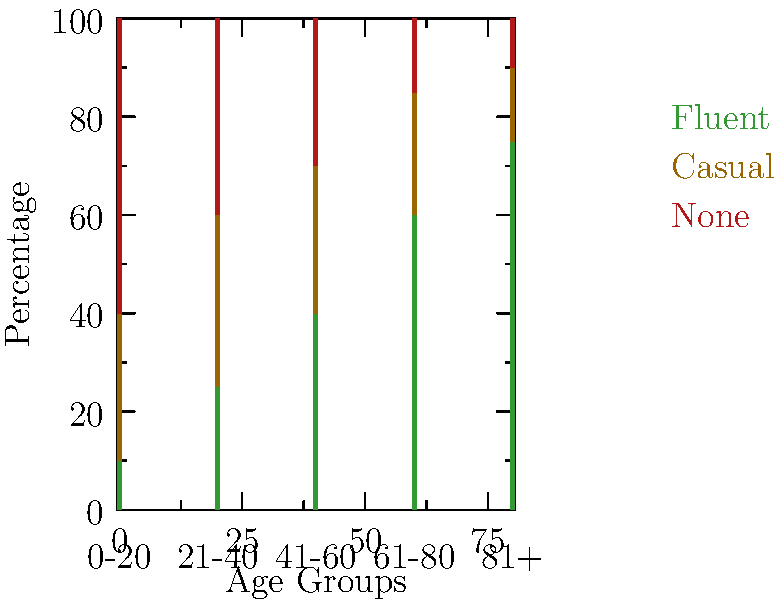Based on the stacked bar chart showing Gaelic language use across different age groups in rural Irish communities, what trend can be observed regarding fluent Gaelic speakers as age increases, and how does this relate to the overall language preservation efforts in your town? To answer this question, let's analyze the data step-by-step:

1. Observe the "Fluent" category (green bars) across age groups:
   - 0-20 age group: About 10% fluent speakers
   - 21-40 age group: About 25% fluent speakers
   - 41-60 age group: About 40% fluent speakers
   - 61-80 age group: About 60% fluent speakers
   - 81+ age group: About 75% fluent speakers

2. Identify the trend:
   As age increases, the percentage of fluent Gaelic speakers also increases. This shows a clear positive correlation between age and fluency in Gaelic.

3. Interpret the trend:
   This trend suggests that older generations are more likely to be fluent in Gaelic compared to younger generations. This could indicate a decline in Gaelic language use among younger people in rural Irish communities.

4. Relate to language preservation efforts:
   The decreasing fluency among younger generations might be a cause for concern in terms of language preservation. This trend could prompt local communities to implement more aggressive language preservation strategies, such as:
   - Increased Gaelic language education in schools
   - Community language programs for all ages
   - Cultural events promoting Gaelic language use
   - Incentives for young people to learn and use Gaelic

5. Consider the "Casual" and "None" categories:
   While fluent speakers decrease in younger age groups, there is a higher percentage of casual speakers among younger generations compared to older ones. This suggests that while full fluency may be declining, there is still some level of Gaelic language engagement among younger people.
Answer: Fluent Gaelic speakers increase with age, indicating potential language loss among younger generations and necessitating stronger preservation efforts. 